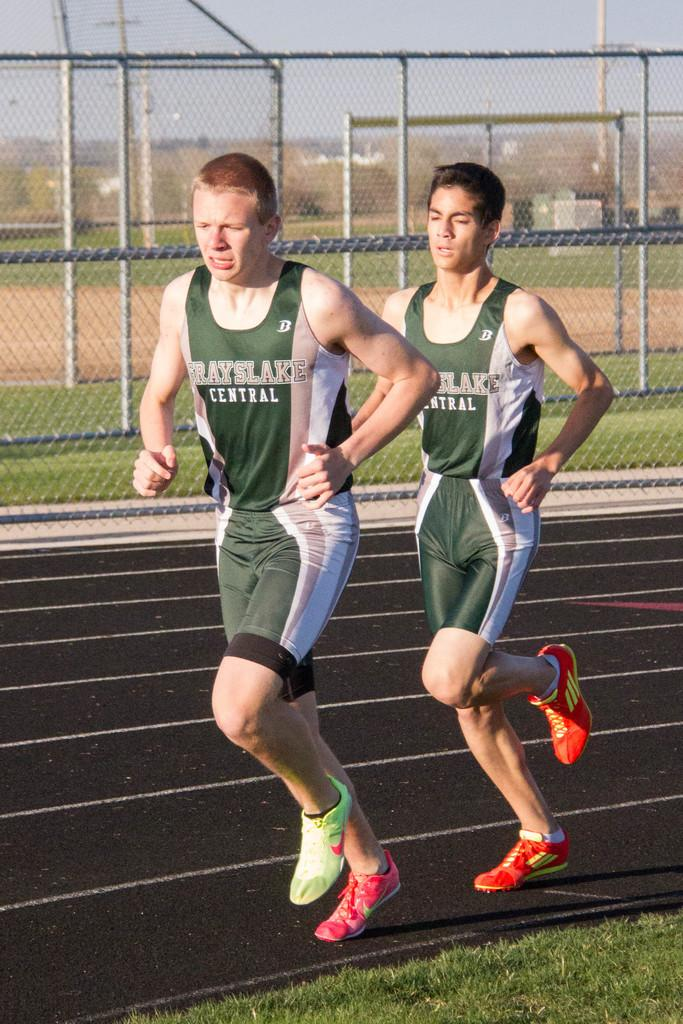<image>
Give a short and clear explanation of the subsequent image. a couple of people running and one has a shirt that says central on it 